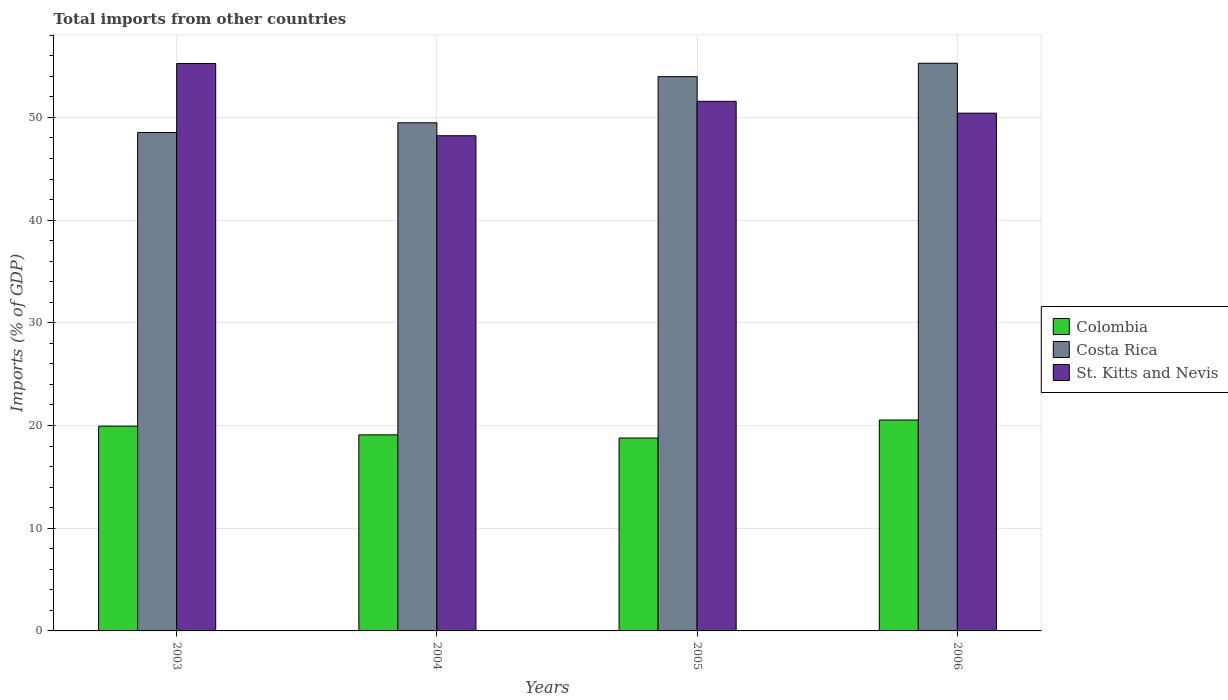How many different coloured bars are there?
Offer a very short reply. 3. How many bars are there on the 3rd tick from the right?
Keep it short and to the point. 3. In how many cases, is the number of bars for a given year not equal to the number of legend labels?
Provide a short and direct response. 0. What is the total imports in Colombia in 2004?
Keep it short and to the point. 19.09. Across all years, what is the maximum total imports in Costa Rica?
Offer a terse response. 55.28. Across all years, what is the minimum total imports in Costa Rica?
Your answer should be compact. 48.54. In which year was the total imports in St. Kitts and Nevis minimum?
Provide a short and direct response. 2004. What is the total total imports in St. Kitts and Nevis in the graph?
Keep it short and to the point. 205.46. What is the difference between the total imports in Costa Rica in 2003 and that in 2006?
Your answer should be very brief. -6.74. What is the difference between the total imports in Costa Rica in 2003 and the total imports in St. Kitts and Nevis in 2004?
Offer a very short reply. 0.32. What is the average total imports in Costa Rica per year?
Make the answer very short. 51.82. In the year 2005, what is the difference between the total imports in St. Kitts and Nevis and total imports in Colombia?
Provide a succinct answer. 32.79. In how many years, is the total imports in Colombia greater than 30 %?
Offer a terse response. 0. What is the ratio of the total imports in Costa Rica in 2004 to that in 2005?
Offer a terse response. 0.92. Is the total imports in Costa Rica in 2003 less than that in 2006?
Your answer should be compact. Yes. What is the difference between the highest and the second highest total imports in Costa Rica?
Your answer should be very brief. 1.3. What is the difference between the highest and the lowest total imports in Colombia?
Provide a succinct answer. 1.75. Is the sum of the total imports in Costa Rica in 2003 and 2005 greater than the maximum total imports in Colombia across all years?
Your response must be concise. Yes. What does the 3rd bar from the right in 2005 represents?
Provide a succinct answer. Colombia. How many bars are there?
Offer a terse response. 12. Are all the bars in the graph horizontal?
Provide a short and direct response. No. How many years are there in the graph?
Make the answer very short. 4. Are the values on the major ticks of Y-axis written in scientific E-notation?
Keep it short and to the point. No. Does the graph contain any zero values?
Keep it short and to the point. No. How many legend labels are there?
Provide a succinct answer. 3. How are the legend labels stacked?
Keep it short and to the point. Vertical. What is the title of the graph?
Offer a very short reply. Total imports from other countries. Does "Switzerland" appear as one of the legend labels in the graph?
Make the answer very short. No. What is the label or title of the X-axis?
Your response must be concise. Years. What is the label or title of the Y-axis?
Your response must be concise. Imports (% of GDP). What is the Imports (% of GDP) in Colombia in 2003?
Give a very brief answer. 19.94. What is the Imports (% of GDP) of Costa Rica in 2003?
Offer a very short reply. 48.54. What is the Imports (% of GDP) of St. Kitts and Nevis in 2003?
Give a very brief answer. 55.26. What is the Imports (% of GDP) of Colombia in 2004?
Offer a very short reply. 19.09. What is the Imports (% of GDP) of Costa Rica in 2004?
Offer a very short reply. 49.48. What is the Imports (% of GDP) in St. Kitts and Nevis in 2004?
Your response must be concise. 48.22. What is the Imports (% of GDP) of Colombia in 2005?
Make the answer very short. 18.78. What is the Imports (% of GDP) of Costa Rica in 2005?
Your answer should be compact. 53.97. What is the Imports (% of GDP) of St. Kitts and Nevis in 2005?
Offer a terse response. 51.57. What is the Imports (% of GDP) of Colombia in 2006?
Make the answer very short. 20.54. What is the Imports (% of GDP) of Costa Rica in 2006?
Keep it short and to the point. 55.28. What is the Imports (% of GDP) of St. Kitts and Nevis in 2006?
Your answer should be compact. 50.42. Across all years, what is the maximum Imports (% of GDP) in Colombia?
Ensure brevity in your answer.  20.54. Across all years, what is the maximum Imports (% of GDP) in Costa Rica?
Your answer should be compact. 55.28. Across all years, what is the maximum Imports (% of GDP) in St. Kitts and Nevis?
Offer a terse response. 55.26. Across all years, what is the minimum Imports (% of GDP) of Colombia?
Your answer should be compact. 18.78. Across all years, what is the minimum Imports (% of GDP) of Costa Rica?
Offer a very short reply. 48.54. Across all years, what is the minimum Imports (% of GDP) in St. Kitts and Nevis?
Offer a terse response. 48.22. What is the total Imports (% of GDP) of Colombia in the graph?
Your answer should be very brief. 78.35. What is the total Imports (% of GDP) of Costa Rica in the graph?
Keep it short and to the point. 207.27. What is the total Imports (% of GDP) in St. Kitts and Nevis in the graph?
Make the answer very short. 205.46. What is the difference between the Imports (% of GDP) in Colombia in 2003 and that in 2004?
Provide a short and direct response. 0.85. What is the difference between the Imports (% of GDP) in Costa Rica in 2003 and that in 2004?
Offer a terse response. -0.95. What is the difference between the Imports (% of GDP) of St. Kitts and Nevis in 2003 and that in 2004?
Offer a very short reply. 7.04. What is the difference between the Imports (% of GDP) in Colombia in 2003 and that in 2005?
Your answer should be very brief. 1.16. What is the difference between the Imports (% of GDP) in Costa Rica in 2003 and that in 2005?
Your answer should be compact. -5.44. What is the difference between the Imports (% of GDP) in St. Kitts and Nevis in 2003 and that in 2005?
Your answer should be very brief. 3.68. What is the difference between the Imports (% of GDP) in Colombia in 2003 and that in 2006?
Ensure brevity in your answer.  -0.6. What is the difference between the Imports (% of GDP) of Costa Rica in 2003 and that in 2006?
Your response must be concise. -6.74. What is the difference between the Imports (% of GDP) of St. Kitts and Nevis in 2003 and that in 2006?
Provide a succinct answer. 4.84. What is the difference between the Imports (% of GDP) of Colombia in 2004 and that in 2005?
Your answer should be compact. 0.31. What is the difference between the Imports (% of GDP) of Costa Rica in 2004 and that in 2005?
Keep it short and to the point. -4.49. What is the difference between the Imports (% of GDP) of St. Kitts and Nevis in 2004 and that in 2005?
Provide a succinct answer. -3.35. What is the difference between the Imports (% of GDP) of Colombia in 2004 and that in 2006?
Offer a very short reply. -1.44. What is the difference between the Imports (% of GDP) in Costa Rica in 2004 and that in 2006?
Provide a short and direct response. -5.8. What is the difference between the Imports (% of GDP) of St. Kitts and Nevis in 2004 and that in 2006?
Your answer should be compact. -2.2. What is the difference between the Imports (% of GDP) of Colombia in 2005 and that in 2006?
Provide a short and direct response. -1.75. What is the difference between the Imports (% of GDP) of Costa Rica in 2005 and that in 2006?
Provide a short and direct response. -1.3. What is the difference between the Imports (% of GDP) of St. Kitts and Nevis in 2005 and that in 2006?
Provide a short and direct response. 1.16. What is the difference between the Imports (% of GDP) of Colombia in 2003 and the Imports (% of GDP) of Costa Rica in 2004?
Keep it short and to the point. -29.54. What is the difference between the Imports (% of GDP) of Colombia in 2003 and the Imports (% of GDP) of St. Kitts and Nevis in 2004?
Make the answer very short. -28.28. What is the difference between the Imports (% of GDP) of Costa Rica in 2003 and the Imports (% of GDP) of St. Kitts and Nevis in 2004?
Your answer should be compact. 0.32. What is the difference between the Imports (% of GDP) of Colombia in 2003 and the Imports (% of GDP) of Costa Rica in 2005?
Offer a terse response. -34.03. What is the difference between the Imports (% of GDP) of Colombia in 2003 and the Imports (% of GDP) of St. Kitts and Nevis in 2005?
Ensure brevity in your answer.  -31.63. What is the difference between the Imports (% of GDP) of Costa Rica in 2003 and the Imports (% of GDP) of St. Kitts and Nevis in 2005?
Ensure brevity in your answer.  -3.04. What is the difference between the Imports (% of GDP) in Colombia in 2003 and the Imports (% of GDP) in Costa Rica in 2006?
Give a very brief answer. -35.34. What is the difference between the Imports (% of GDP) of Colombia in 2003 and the Imports (% of GDP) of St. Kitts and Nevis in 2006?
Your response must be concise. -30.48. What is the difference between the Imports (% of GDP) in Costa Rica in 2003 and the Imports (% of GDP) in St. Kitts and Nevis in 2006?
Your answer should be compact. -1.88. What is the difference between the Imports (% of GDP) in Colombia in 2004 and the Imports (% of GDP) in Costa Rica in 2005?
Your answer should be very brief. -34.88. What is the difference between the Imports (% of GDP) of Colombia in 2004 and the Imports (% of GDP) of St. Kitts and Nevis in 2005?
Provide a succinct answer. -32.48. What is the difference between the Imports (% of GDP) of Costa Rica in 2004 and the Imports (% of GDP) of St. Kitts and Nevis in 2005?
Make the answer very short. -2.09. What is the difference between the Imports (% of GDP) in Colombia in 2004 and the Imports (% of GDP) in Costa Rica in 2006?
Offer a very short reply. -36.18. What is the difference between the Imports (% of GDP) of Colombia in 2004 and the Imports (% of GDP) of St. Kitts and Nevis in 2006?
Provide a short and direct response. -31.32. What is the difference between the Imports (% of GDP) in Costa Rica in 2004 and the Imports (% of GDP) in St. Kitts and Nevis in 2006?
Provide a short and direct response. -0.94. What is the difference between the Imports (% of GDP) of Colombia in 2005 and the Imports (% of GDP) of Costa Rica in 2006?
Offer a very short reply. -36.49. What is the difference between the Imports (% of GDP) of Colombia in 2005 and the Imports (% of GDP) of St. Kitts and Nevis in 2006?
Give a very brief answer. -31.63. What is the difference between the Imports (% of GDP) of Costa Rica in 2005 and the Imports (% of GDP) of St. Kitts and Nevis in 2006?
Keep it short and to the point. 3.56. What is the average Imports (% of GDP) of Colombia per year?
Your answer should be very brief. 19.59. What is the average Imports (% of GDP) in Costa Rica per year?
Offer a terse response. 51.82. What is the average Imports (% of GDP) in St. Kitts and Nevis per year?
Ensure brevity in your answer.  51.37. In the year 2003, what is the difference between the Imports (% of GDP) of Colombia and Imports (% of GDP) of Costa Rica?
Your answer should be compact. -28.59. In the year 2003, what is the difference between the Imports (% of GDP) of Colombia and Imports (% of GDP) of St. Kitts and Nevis?
Your answer should be compact. -35.31. In the year 2003, what is the difference between the Imports (% of GDP) in Costa Rica and Imports (% of GDP) in St. Kitts and Nevis?
Make the answer very short. -6.72. In the year 2004, what is the difference between the Imports (% of GDP) of Colombia and Imports (% of GDP) of Costa Rica?
Provide a succinct answer. -30.39. In the year 2004, what is the difference between the Imports (% of GDP) of Colombia and Imports (% of GDP) of St. Kitts and Nevis?
Offer a terse response. -29.13. In the year 2004, what is the difference between the Imports (% of GDP) of Costa Rica and Imports (% of GDP) of St. Kitts and Nevis?
Your response must be concise. 1.26. In the year 2005, what is the difference between the Imports (% of GDP) in Colombia and Imports (% of GDP) in Costa Rica?
Give a very brief answer. -35.19. In the year 2005, what is the difference between the Imports (% of GDP) in Colombia and Imports (% of GDP) in St. Kitts and Nevis?
Give a very brief answer. -32.79. In the year 2005, what is the difference between the Imports (% of GDP) of Costa Rica and Imports (% of GDP) of St. Kitts and Nevis?
Provide a succinct answer. 2.4. In the year 2006, what is the difference between the Imports (% of GDP) in Colombia and Imports (% of GDP) in Costa Rica?
Ensure brevity in your answer.  -34.74. In the year 2006, what is the difference between the Imports (% of GDP) in Colombia and Imports (% of GDP) in St. Kitts and Nevis?
Your response must be concise. -29.88. In the year 2006, what is the difference between the Imports (% of GDP) of Costa Rica and Imports (% of GDP) of St. Kitts and Nevis?
Give a very brief answer. 4.86. What is the ratio of the Imports (% of GDP) in Colombia in 2003 to that in 2004?
Offer a terse response. 1.04. What is the ratio of the Imports (% of GDP) in Costa Rica in 2003 to that in 2004?
Provide a short and direct response. 0.98. What is the ratio of the Imports (% of GDP) of St. Kitts and Nevis in 2003 to that in 2004?
Offer a very short reply. 1.15. What is the ratio of the Imports (% of GDP) of Colombia in 2003 to that in 2005?
Your response must be concise. 1.06. What is the ratio of the Imports (% of GDP) in Costa Rica in 2003 to that in 2005?
Provide a short and direct response. 0.9. What is the ratio of the Imports (% of GDP) in St. Kitts and Nevis in 2003 to that in 2005?
Make the answer very short. 1.07. What is the ratio of the Imports (% of GDP) in Costa Rica in 2003 to that in 2006?
Offer a very short reply. 0.88. What is the ratio of the Imports (% of GDP) in St. Kitts and Nevis in 2003 to that in 2006?
Provide a short and direct response. 1.1. What is the ratio of the Imports (% of GDP) of Colombia in 2004 to that in 2005?
Offer a terse response. 1.02. What is the ratio of the Imports (% of GDP) in Costa Rica in 2004 to that in 2005?
Your response must be concise. 0.92. What is the ratio of the Imports (% of GDP) in St. Kitts and Nevis in 2004 to that in 2005?
Your response must be concise. 0.94. What is the ratio of the Imports (% of GDP) in Colombia in 2004 to that in 2006?
Your answer should be compact. 0.93. What is the ratio of the Imports (% of GDP) in Costa Rica in 2004 to that in 2006?
Provide a succinct answer. 0.9. What is the ratio of the Imports (% of GDP) of St. Kitts and Nevis in 2004 to that in 2006?
Keep it short and to the point. 0.96. What is the ratio of the Imports (% of GDP) in Colombia in 2005 to that in 2006?
Offer a very short reply. 0.91. What is the ratio of the Imports (% of GDP) in Costa Rica in 2005 to that in 2006?
Keep it short and to the point. 0.98. What is the ratio of the Imports (% of GDP) of St. Kitts and Nevis in 2005 to that in 2006?
Make the answer very short. 1.02. What is the difference between the highest and the second highest Imports (% of GDP) in Colombia?
Give a very brief answer. 0.6. What is the difference between the highest and the second highest Imports (% of GDP) of Costa Rica?
Ensure brevity in your answer.  1.3. What is the difference between the highest and the second highest Imports (% of GDP) of St. Kitts and Nevis?
Provide a succinct answer. 3.68. What is the difference between the highest and the lowest Imports (% of GDP) of Colombia?
Your answer should be very brief. 1.75. What is the difference between the highest and the lowest Imports (% of GDP) in Costa Rica?
Offer a very short reply. 6.74. What is the difference between the highest and the lowest Imports (% of GDP) in St. Kitts and Nevis?
Provide a short and direct response. 7.04. 